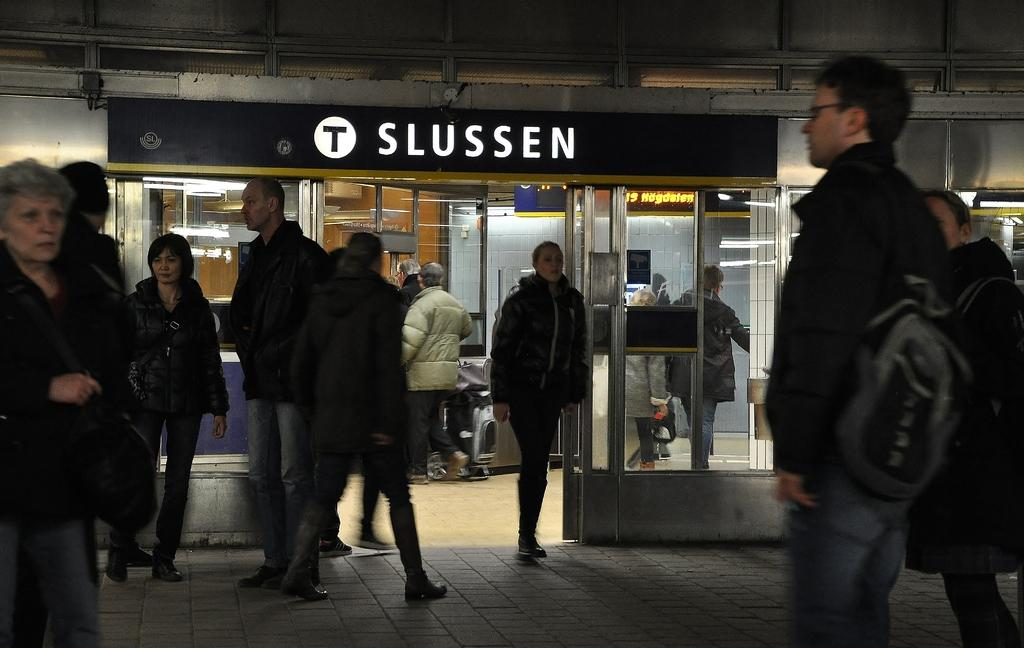What is the main subject of the image? The main subject of the image is groups of people standing. What type of location does the image appear to depict? The image appears to depict a store. What can be seen on the wall in the image? There is a name board fixed to a wall in the image. What type of doors are visible in the image? There are glass doors visible in the image. What type of fish can be seen swimming in the image? There are no fish present in the image; it depicts a store with people standing and glass doors. 